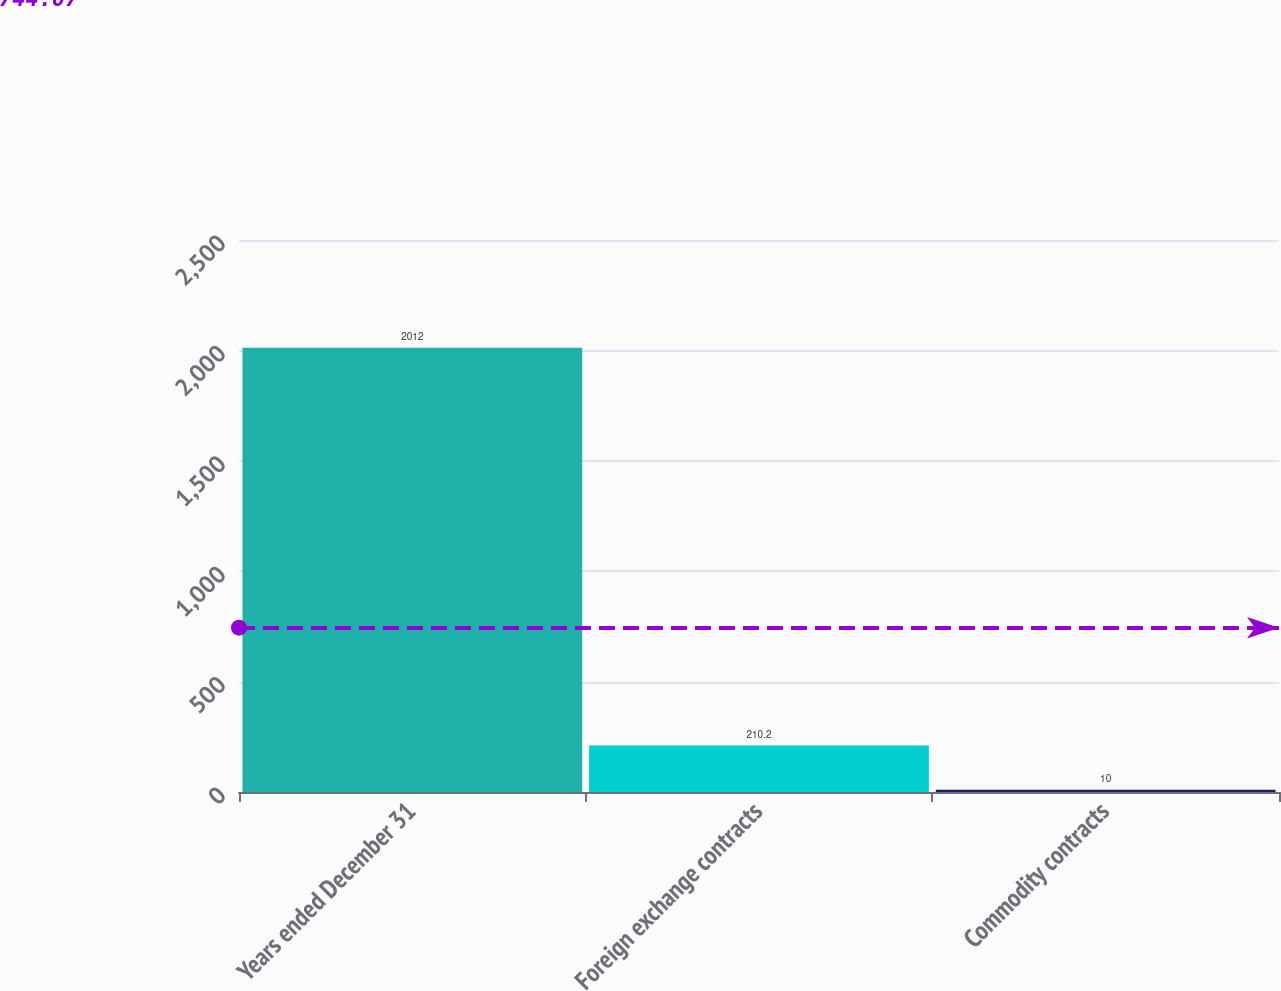Convert chart to OTSL. <chart><loc_0><loc_0><loc_500><loc_500><bar_chart><fcel>Years ended December 31<fcel>Foreign exchange contracts<fcel>Commodity contracts<nl><fcel>2012<fcel>210.2<fcel>10<nl></chart> 